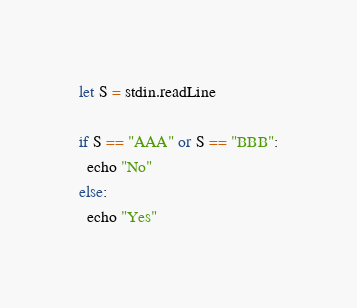Convert code to text. <code><loc_0><loc_0><loc_500><loc_500><_Nim_>let S = stdin.readLine

if S == "AAA" or S == "BBB":
  echo "No"
else:
  echo "Yes"
</code> 